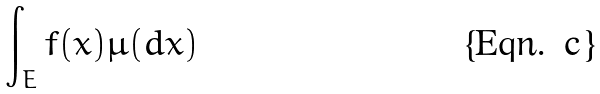Convert formula to latex. <formula><loc_0><loc_0><loc_500><loc_500>\int _ { E } f ( x ) \mu ( d x )</formula> 